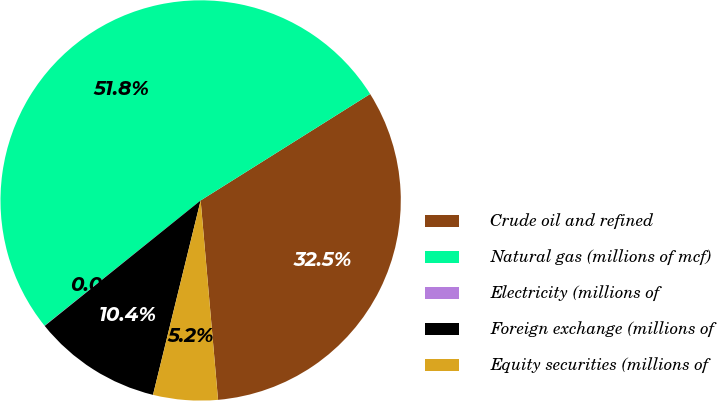<chart> <loc_0><loc_0><loc_500><loc_500><pie_chart><fcel>Crude oil and refined<fcel>Natural gas (millions of mcf)<fcel>Electricity (millions of<fcel>Foreign exchange (millions of<fcel>Equity securities (millions of<nl><fcel>32.54%<fcel>51.84%<fcel>0.02%<fcel>10.39%<fcel>5.21%<nl></chart> 